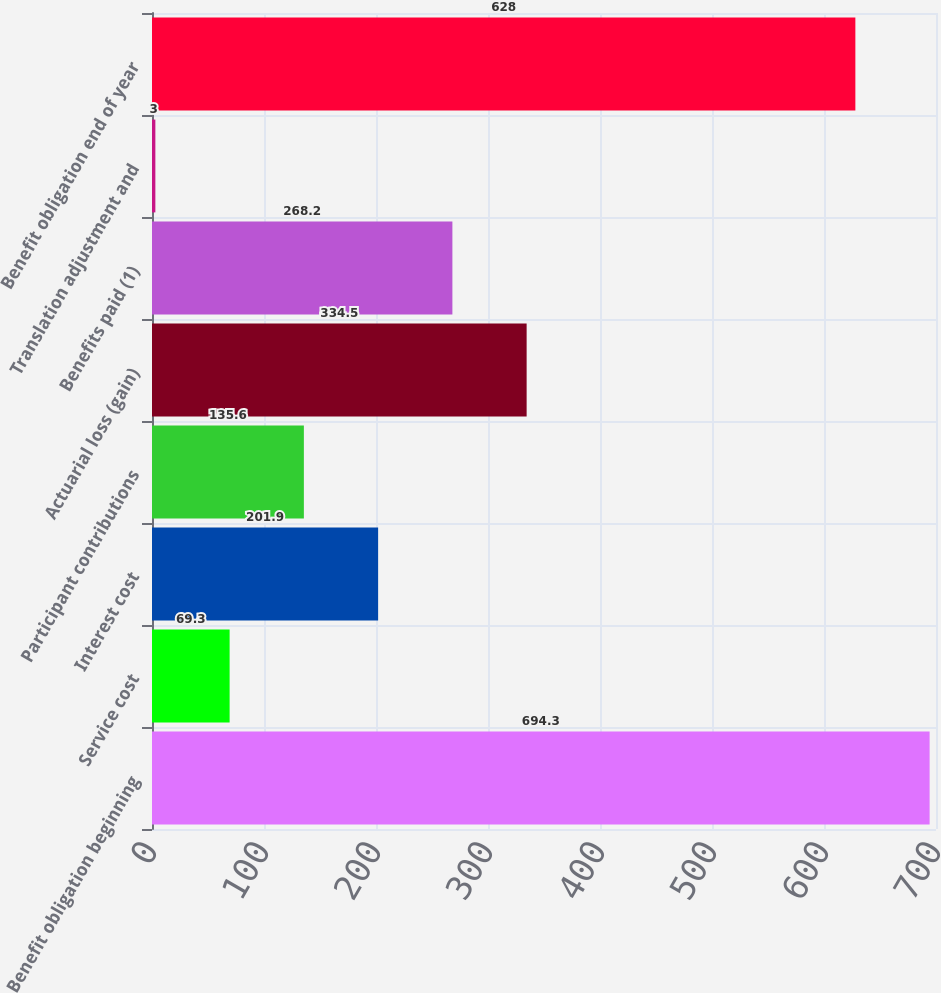Convert chart. <chart><loc_0><loc_0><loc_500><loc_500><bar_chart><fcel>Benefit obligation beginning<fcel>Service cost<fcel>Interest cost<fcel>Participant contributions<fcel>Actuarial loss (gain)<fcel>Benefits paid (1)<fcel>Translation adjustment and<fcel>Benefit obligation end of year<nl><fcel>694.3<fcel>69.3<fcel>201.9<fcel>135.6<fcel>334.5<fcel>268.2<fcel>3<fcel>628<nl></chart> 